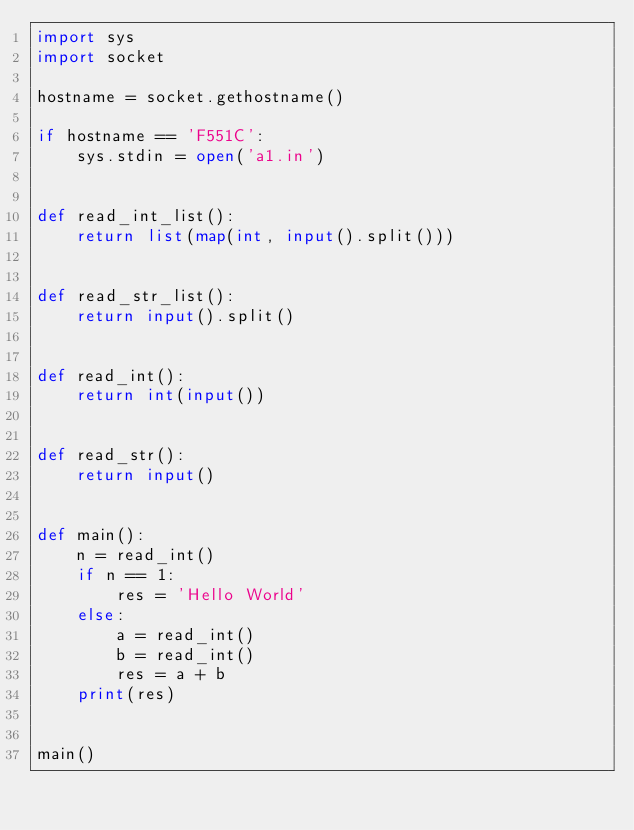Convert code to text. <code><loc_0><loc_0><loc_500><loc_500><_Python_>import sys
import socket

hostname = socket.gethostname()

if hostname == 'F551C':
    sys.stdin = open('a1.in')


def read_int_list():
    return list(map(int, input().split()))


def read_str_list():
    return input().split()


def read_int():
    return int(input())


def read_str():
    return input()


def main():
    n = read_int()
    if n == 1:
        res = 'Hello World'
    else:
        a = read_int()
        b = read_int()
        res = a + b
    print(res)


main()
</code> 